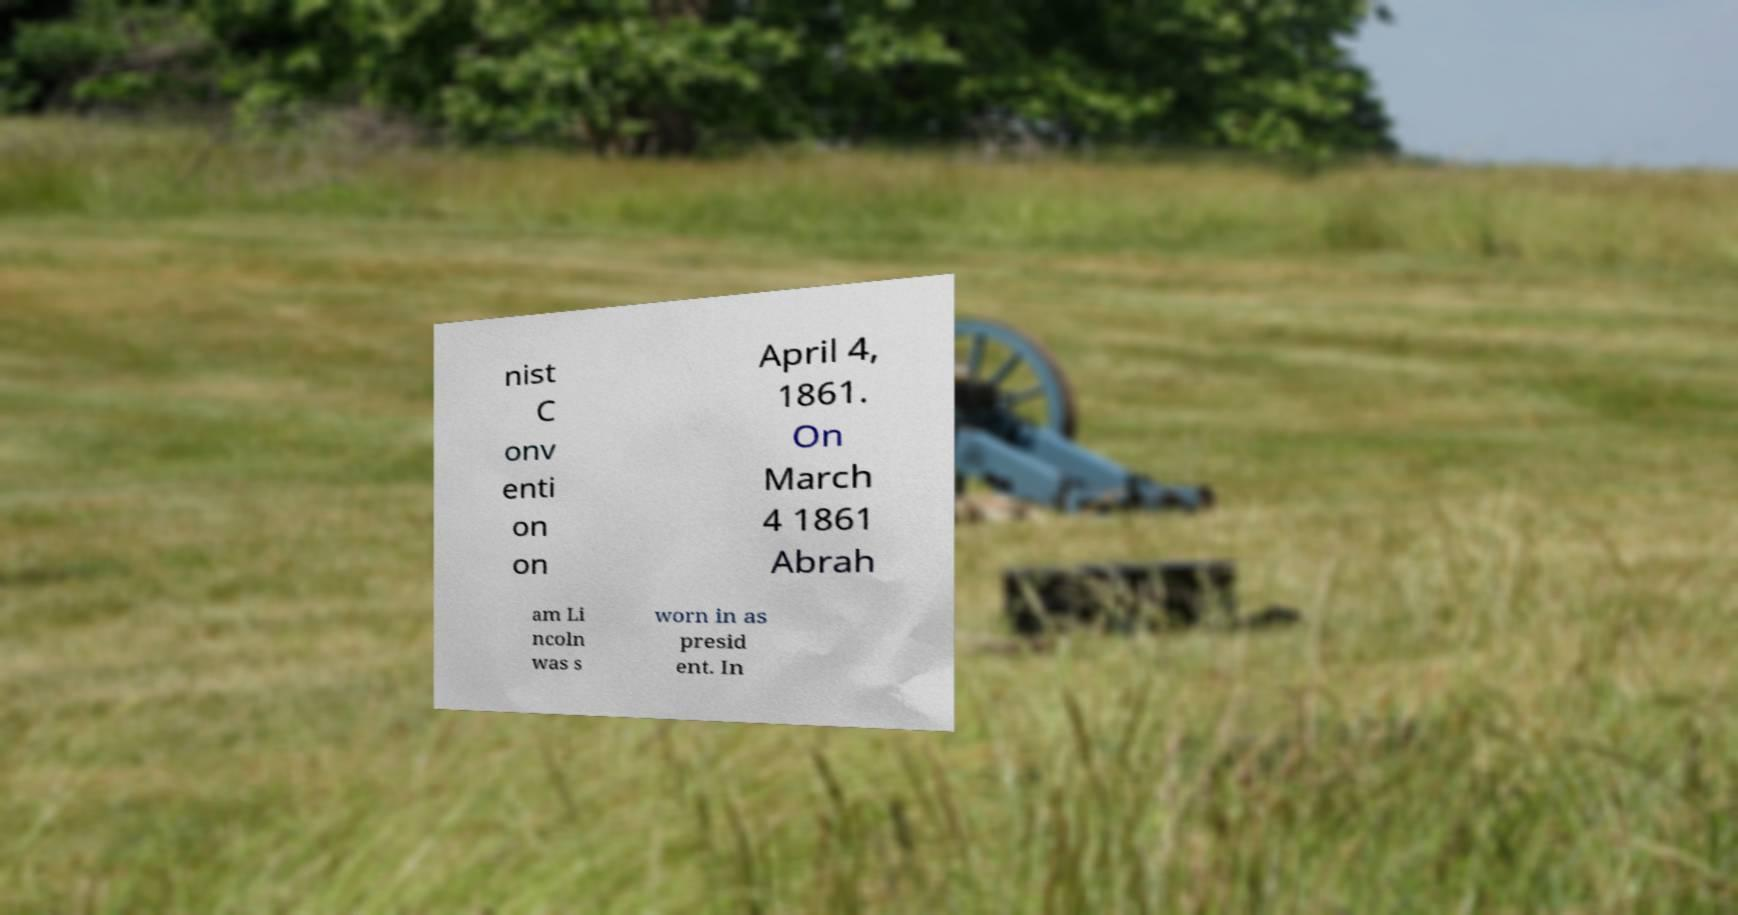Can you accurately transcribe the text from the provided image for me? nist C onv enti on on April 4, 1861. On March 4 1861 Abrah am Li ncoln was s worn in as presid ent. In 